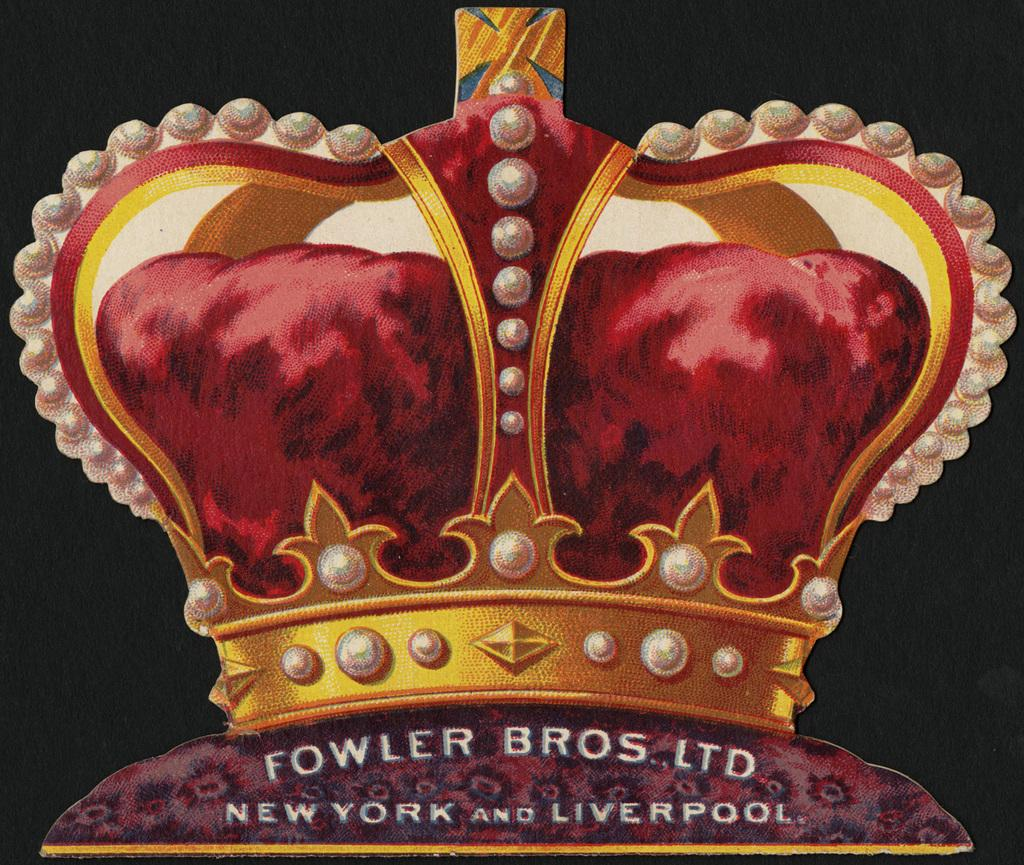What type of image is being described? The image is a poster. What is the main feature of the poster? There is a crown in the poster. Are there any additional details on the crown? Yes, there is text on the crown. What type of shoes are depicted on the crown in the image? There are no shoes present on the crown in the image; the crown only has text on it. 